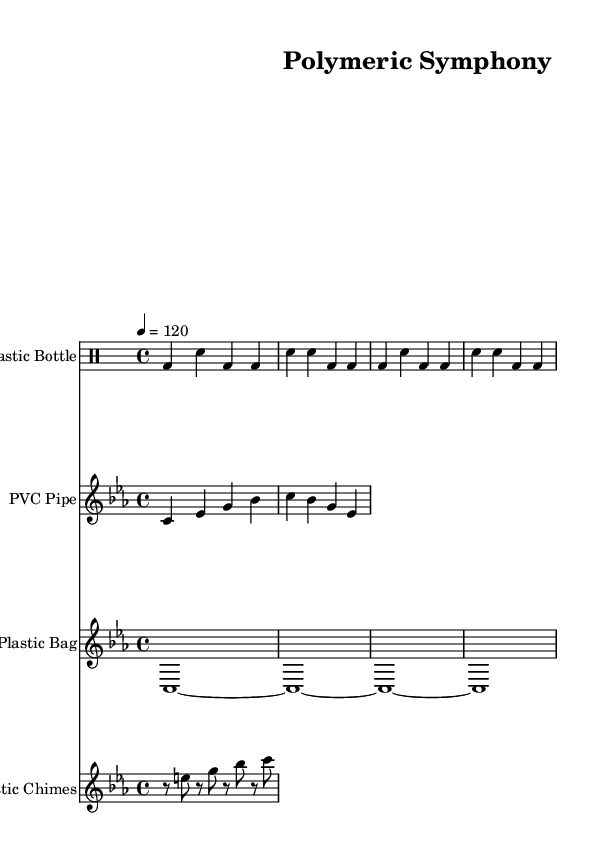What is the key signature of this music? The key signature is indicated by the 'c' in "c minor," which shows it has three flats (B♭, E♭, A♭).
Answer: C minor What is the time signature of this piece? The time signature is shown as "4/4" at the beginning of the score, indicating four beats in each measure.
Answer: 4/4 What is the tempo marking? The tempo is indicated by "4 = 120," meaning there are 120 beats per minute (BPM) for the quarter note.
Answer: 120 How many measures are there in the plastic bottle percussion part? Counting the repeated section in the drum staff, there are four measures in total (two measures repeated).
Answer: 4 What is the duration of the plastic bag drone sound? The plastic bag drone is notated as a whole note "c1", which lasts for four beats (the entire measure).
Answer: Whole note What instruments are used in this composition? The instruments are listed at the start of each staff: Plastic Bottle, PVC Pipe, Plastic Bag, and Plastic Chimes.
Answer: Plastic Bottle, PVC Pipe, Plastic Bag, Plastic Chimes What type of music does this score represent? The score includes various experimental techniques using recycled materials, indicating an innovative approach to contemporary music composition.
Answer: Experimental electronic music 